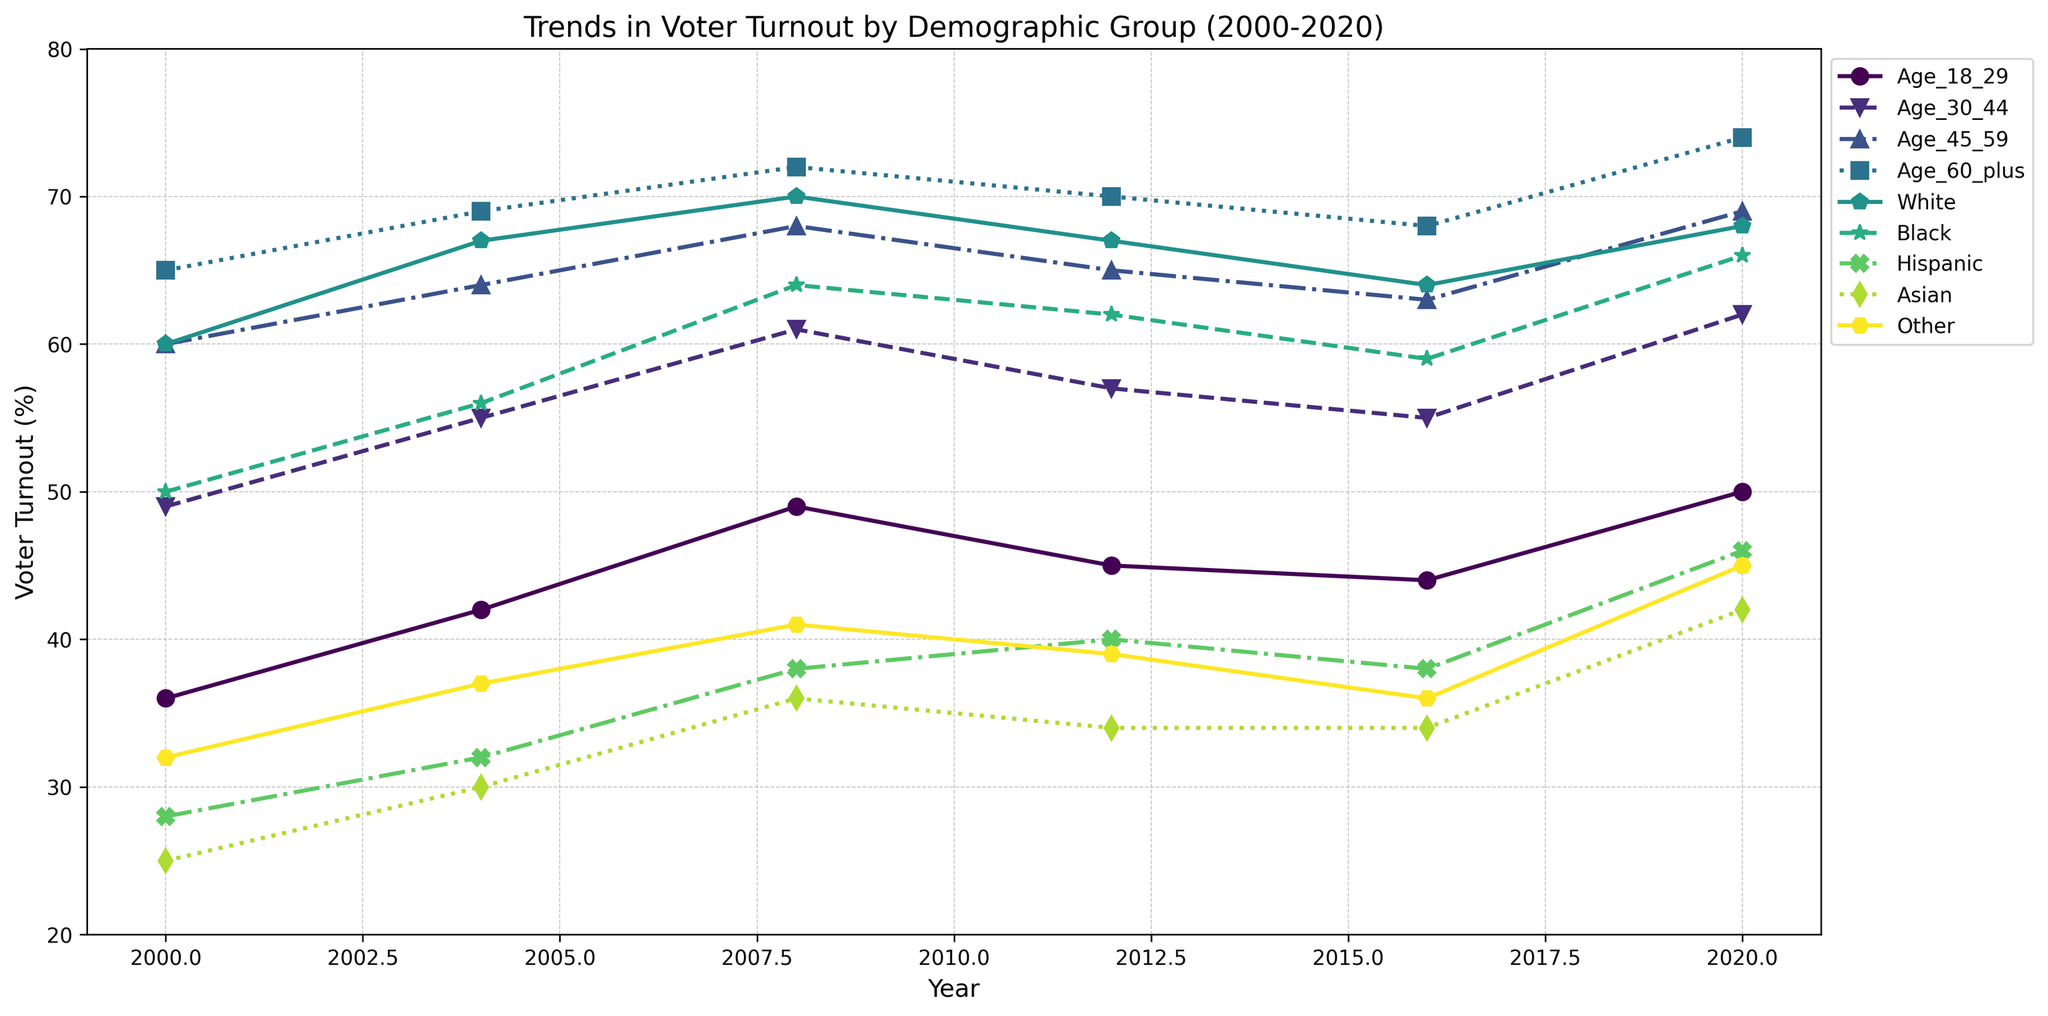What was the voter turnout for Age 60+ and Black demographics in 2020? Identify the points on the graph corresponding to Age 60+ and Black demographics for the year 2020. Both points are labeled; Age 60+ shows 74% and Black shows 66%.
Answer: Age 60+: 74%, Black: 66% Which demographic group had the lowest voter turnout in 2004? Compare the voter turnout percentages for all demographic groups in 2004. The Hispanic group has the lowest turnout at 32%.
Answer: Hispanic: 32% What is the difference between the voter turnout of White and Hispanic demographics in 2020? Identify the voter turnout percentages for White and Hispanic groups in 2020, which are 68% and 46%, respectively. Subtract the Hispanic turnout from the White turnout (68% - 46% = 22%).
Answer: 22% By how much did the voter turnout for Age 18-29 change from 2000 to 2020? Note the voter turnout for Age 18-29 in 2000 and 2020, which are 36% and 50%, respectively. Calculate the difference (50% - 36% = 14%).
Answer: 14% Which age group had the largest increase in voter turnout from 2000 to 2020? Compare the changes in voter turnout for each age group between 2000 and 2020. Age 18-29 increased from 36% to 50% (14%), Age 30-44 from 49% to 62% (13%), Age 45-59 from 60% to 69% (9%), and Age 60+ from 65% to 74% (9%). The largest increase is for Age 18-29.
Answer: Age 18-29 What is the average voter turnout for Hispanic demographics across all years shown? Sum the voter turnout percentages for Hispanic demographics across all years and divide by the number of years. Calculation: (28% + 32% + 38% + 40% + 38% + 46%) / 6 = 222 / 6 = 37%.
Answer: 37% Which demographic groups had a higher turnout in 2020 compared to 2008? Compare the voter turnout for each demographic group in 2008 and 2020. Groups with higher turnout in 2020 than in 2008 are Age 18-29 (50% vs. 49%), Age 30-44 (62% vs. 61%), Hispanic (46% vs. 38%), and Asian (42% vs. 36%).
Answer: Age 18-29, Age 30-44, Hispanic, Asian In which year did White demographics surpass 65% voter turnout for the first time? Examine the points on the graph representing White demographics. In 2000, it was 60%, in 2004, it was 67% which is the first time surpassing 65%.
Answer: 2004 What are the maximum and minimum voter turnouts for the Age 60+ group observed in the given years? Identify the voter turnout percentages for Age 60+ across different years: 65%, 69%, 72%, 70%, 68%, and 74%. The maximum is 74% (2020), and the minimum is 65% (2000).
Answer: Maximum: 74%, Minimum: 65% 